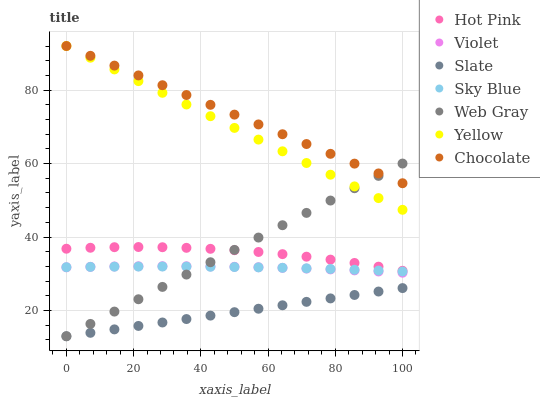Does Slate have the minimum area under the curve?
Answer yes or no. Yes. Does Chocolate have the maximum area under the curve?
Answer yes or no. Yes. Does Hot Pink have the minimum area under the curve?
Answer yes or no. No. Does Hot Pink have the maximum area under the curve?
Answer yes or no. No. Is Slate the smoothest?
Answer yes or no. Yes. Is Hot Pink the roughest?
Answer yes or no. Yes. Is Hot Pink the smoothest?
Answer yes or no. No. Is Slate the roughest?
Answer yes or no. No. Does Web Gray have the lowest value?
Answer yes or no. Yes. Does Hot Pink have the lowest value?
Answer yes or no. No. Does Chocolate have the highest value?
Answer yes or no. Yes. Does Hot Pink have the highest value?
Answer yes or no. No. Is Hot Pink less than Yellow?
Answer yes or no. Yes. Is Sky Blue greater than Slate?
Answer yes or no. Yes. Does Chocolate intersect Yellow?
Answer yes or no. Yes. Is Chocolate less than Yellow?
Answer yes or no. No. Is Chocolate greater than Yellow?
Answer yes or no. No. Does Hot Pink intersect Yellow?
Answer yes or no. No. 